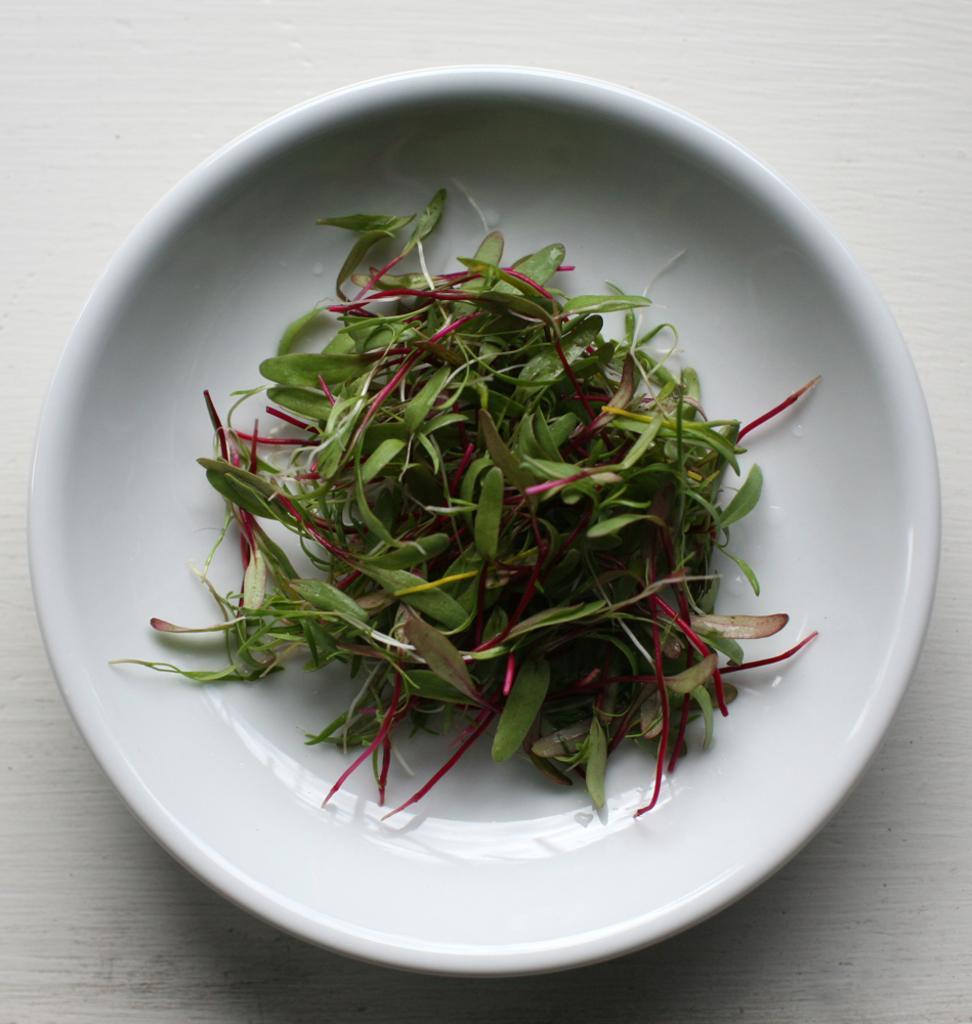Please provide a concise description of this image. In this picture I can see few leaves in a plate. 